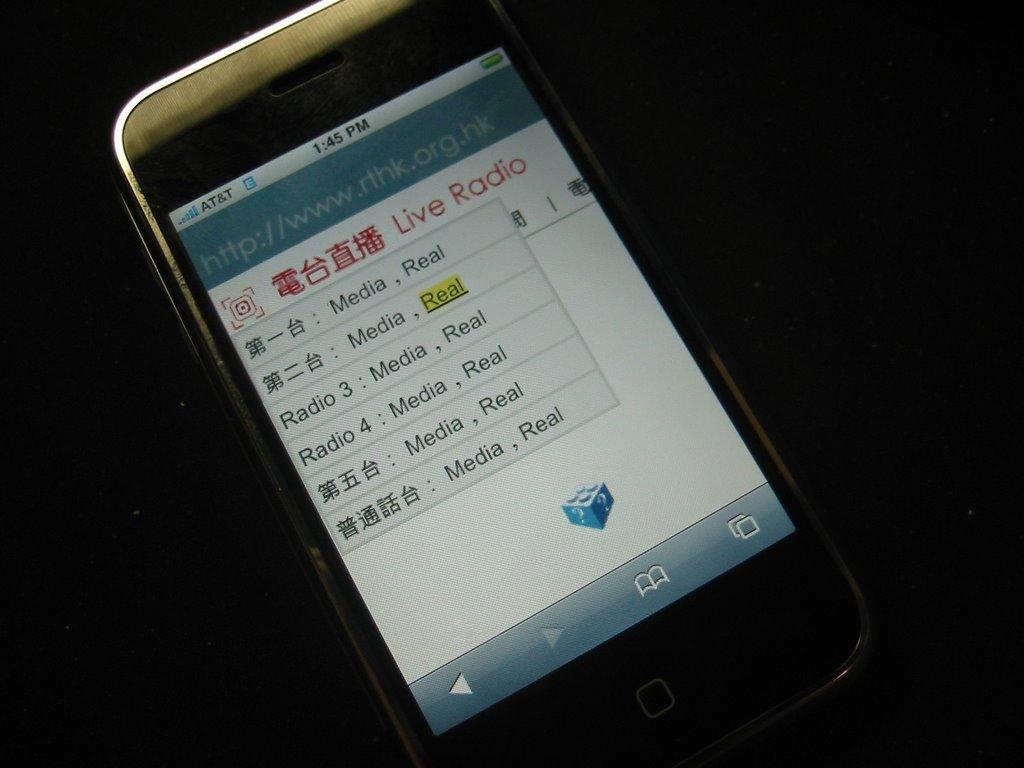<image>
Describe the image concisely. The screen of a phone that has a list of several radio stations being displayed. 